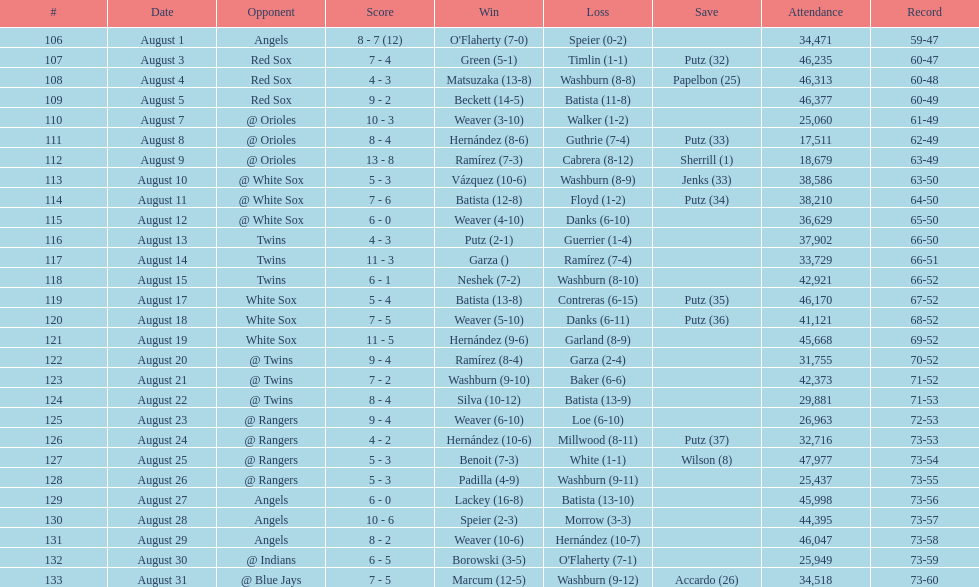How many losses during stretch? 7. 